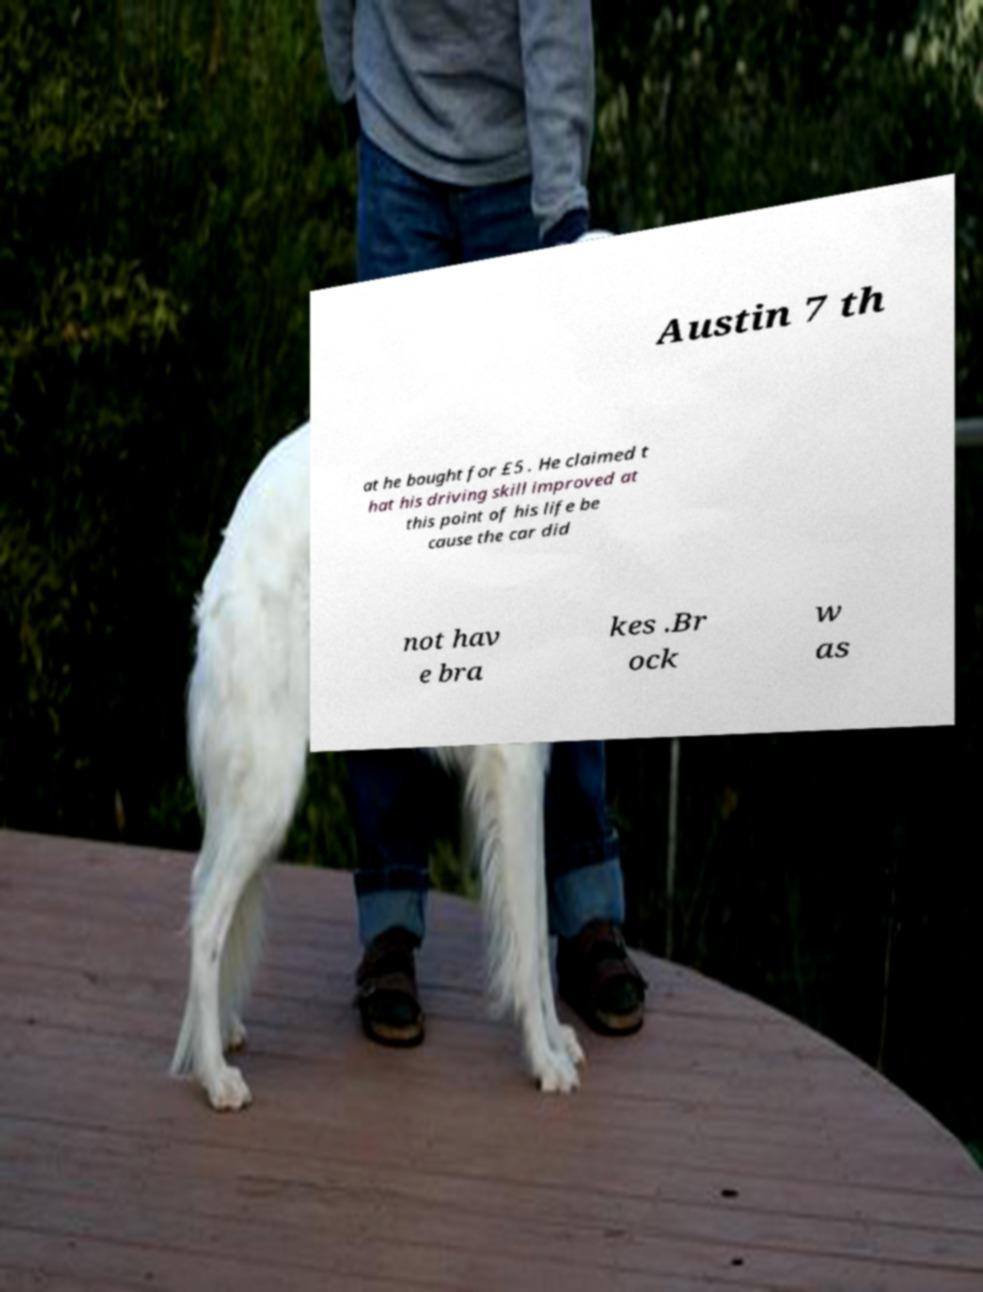What messages or text are displayed in this image? I need them in a readable, typed format. Austin 7 th at he bought for £5 . He claimed t hat his driving skill improved at this point of his life be cause the car did not hav e bra kes .Br ock w as 